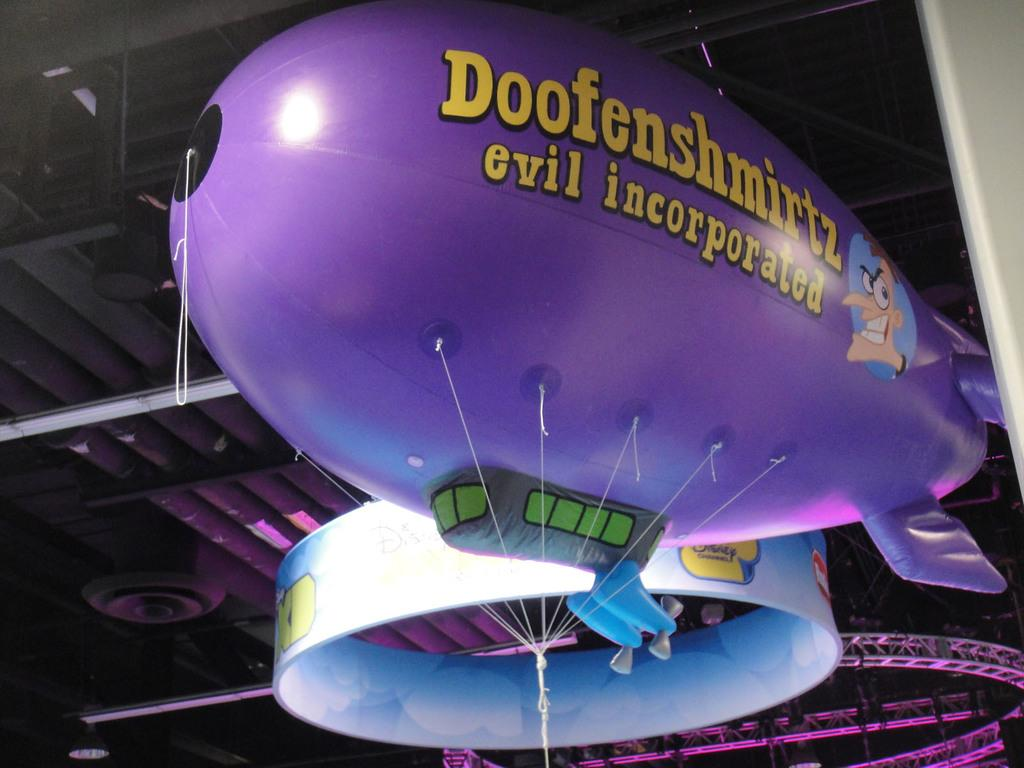What is attached to the ropes in the image? There is a balloon with text and a picture in the image, and it is tied with ropes. What can be seen in the background of the image? In the background of the image, there is a ring, metal frames, poles, and lights. What might the balloon be used for in the image? The balloon could be used for decoration or as a sign, given the text and picture on it. What type of sense can be seen in the image? There is no sense present in the image; it features a balloon with text and a picture, tied with ropes, and objects in the background. Can you tell me how many moons are visible in the image? There is no moon visible in the image; it features a balloon and objects in the background. 